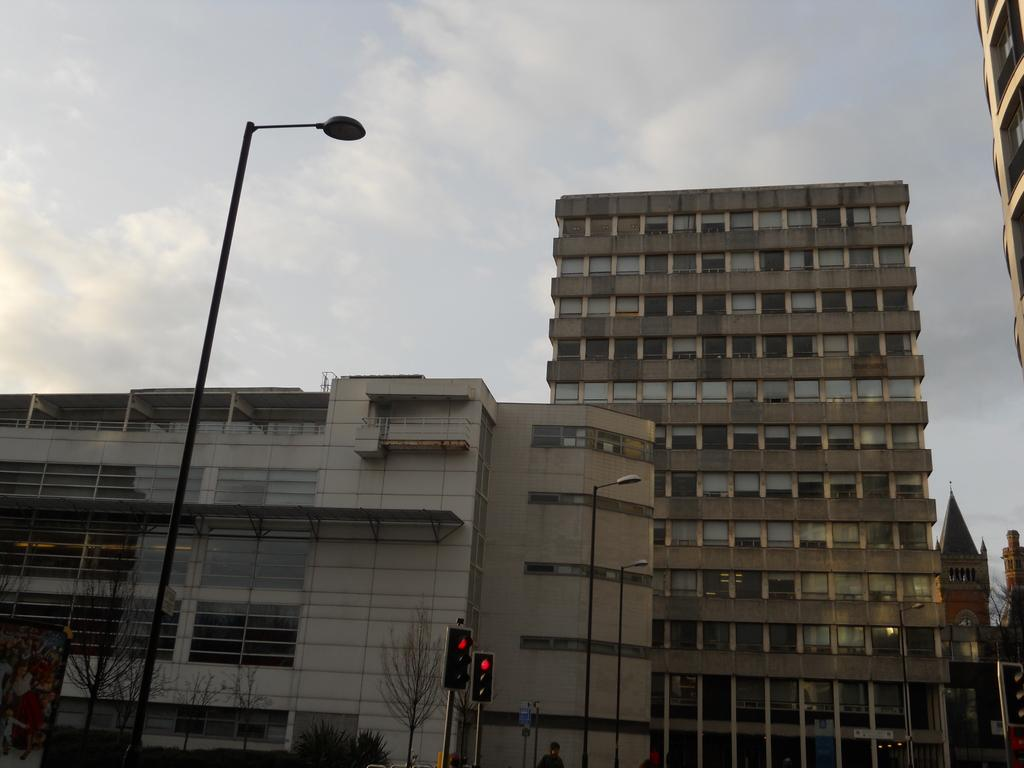What is the main object in the image? There is a board in the image. What type of lights can be seen in the image? Signal lights and lights attached to poles are present in the image. What type of vegetation is visible in the image? There are trees in the image. What type of structures can be seen in the image? Buildings are visible in the image. What is visible in the sky in the image? The sky is visible in the image. How many sisters are holding linen in the image? There are no sisters or linen present in the image. What type of writing instrument is being used by the person in the image? There is no person or quill present in the image. 